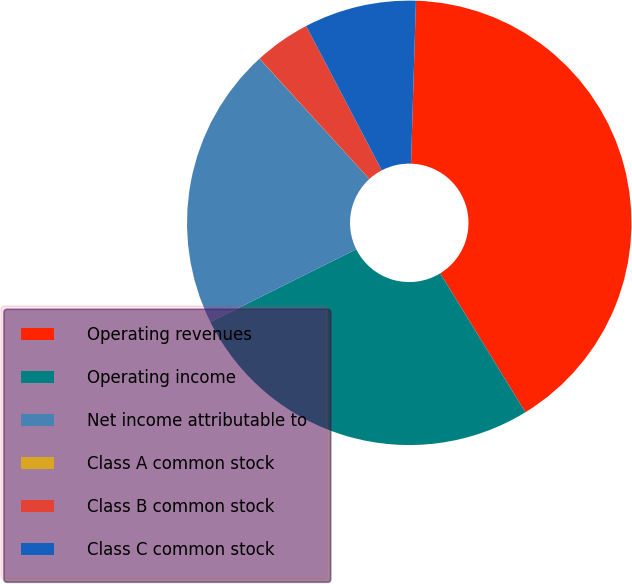<chart> <loc_0><loc_0><loc_500><loc_500><pie_chart><fcel>Operating revenues<fcel>Operating income<fcel>Net income attributable to<fcel>Class A common stock<fcel>Class B common stock<fcel>Class C common stock<nl><fcel>40.76%<fcel>26.39%<fcel>20.59%<fcel>0.01%<fcel>4.08%<fcel>8.16%<nl></chart> 